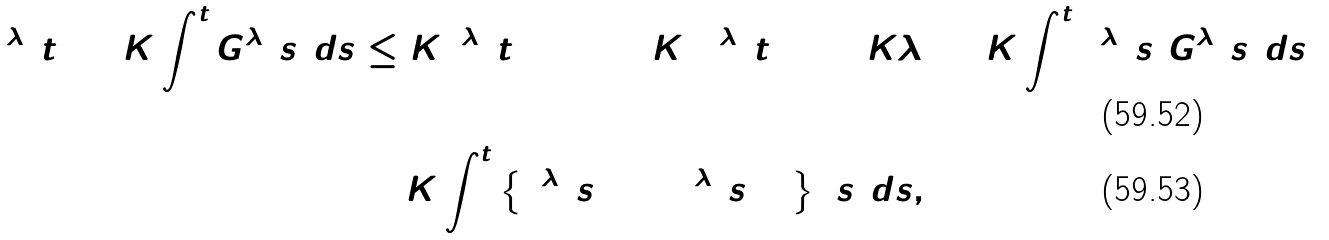<formula> <loc_0><loc_0><loc_500><loc_500>\Gamma ^ { \lambda } ( t ) + K \int ^ { t } _ { 0 } G ^ { \lambda } ( s ) d s & \leq K \bar { \Gamma } ^ { \lambda } ( t = 0 ) + K ( \Gamma ^ { \lambda } ( t ) ) ^ { 2 } + K \lambda ^ { 4 } + K \int ^ { t } _ { 0 } \Gamma ^ { \lambda } ( s ) G ^ { \lambda } ( s ) d s \\ & + K \int ^ { t } _ { 0 } \left \{ \Gamma ^ { \lambda } ( s ) + ( \Gamma ^ { \lambda } ( s ) ) ^ { 2 } \right \} ( s ) d s ,</formula> 